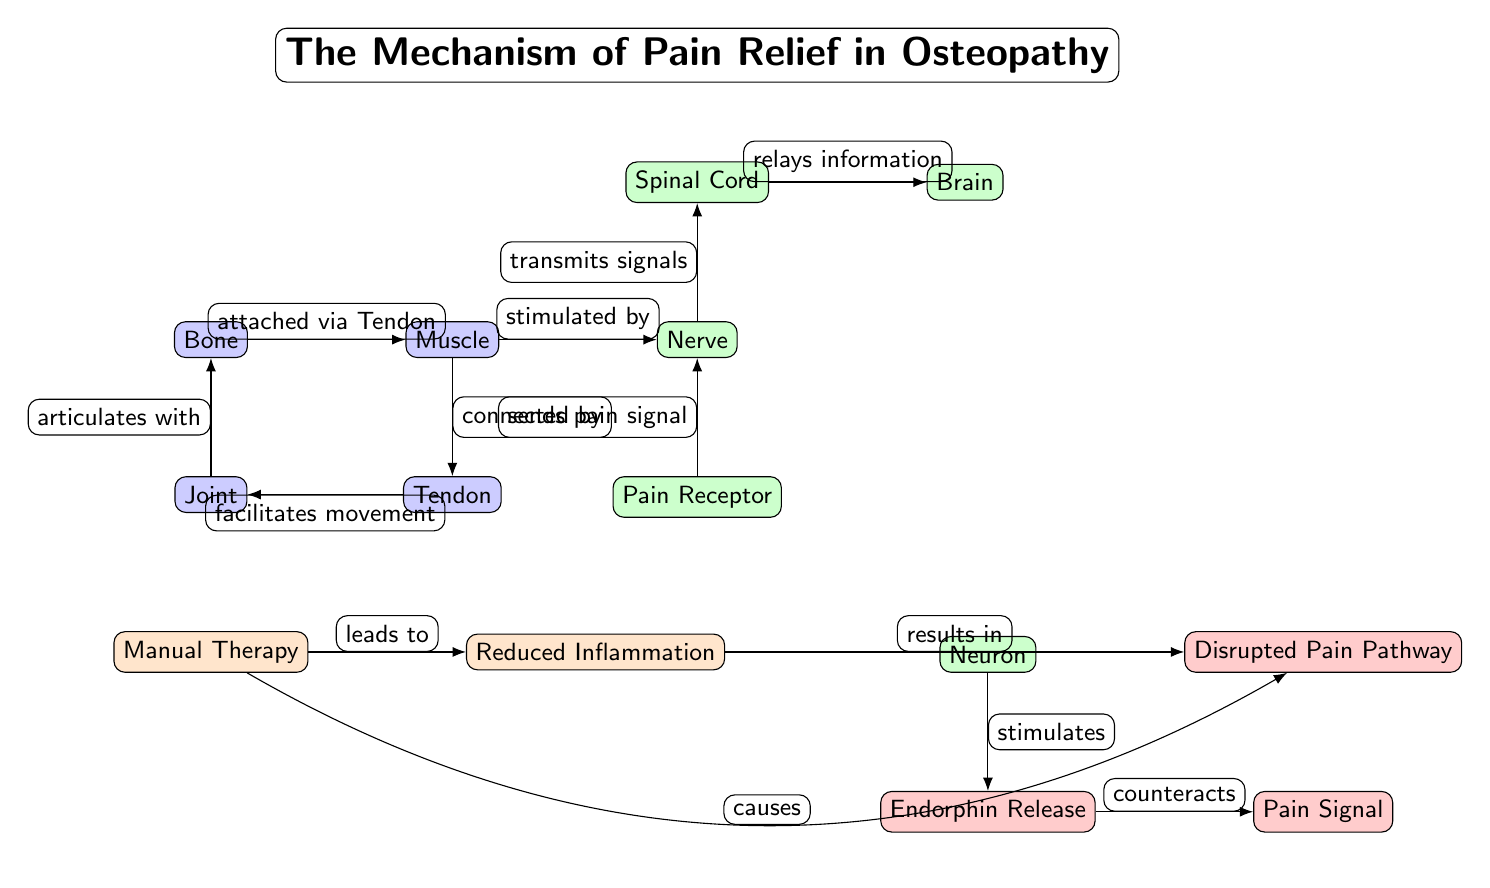What is the title of the diagram? The title is located at the top of the diagram, indicating the main subject being illustrated. It reads "The Mechanism of Pain Relief in Osteopathy."
Answer: The Mechanism of Pain Relief in Osteopathy How many musculoskeletal components are shown in the diagram? The diagram contains four musculoskeletal components: Bone, Muscle, Tendon, and Joint. By counting these nodes specifically, we arrive at the total.
Answer: 4 Which node sends a pain signal to the Nerve? The Pain Receptor node is indicated as sending a pain signal to the Nerve. This is clearly shown through the edge connecting these two nodes.
Answer: Pain Receptor What relationship does the Joint have with the Bone? The edge between Joint and Bone is labeled "articulates with," describing the connection between these two components in the musculoskeletal system.
Answer: articulates with What leads to the Reduced Inflammation in the diagram? The Manual Therapy node is indicated as the cause of Reduced Inflammation. This relationship is shown through the directed edge connecting the two.
Answer: Manual Therapy What is the final effect of Endorphin Release according to the diagram? The Endorphin Release node is connected to the Pain Signal node, with the edge labeled "counteracts," indicating the effect of endorphins on pain signals.
Answer: counteracts How does the Manual Therapy affect the Pain Pathway? Manual Therapy is described as causing a Disrupted Pain Pathway, which is depicted with an edge bending towards the Disrupted Pain Pathway node. This indicates a direct therapeutic effect.
Answer: causes Which components are part of the neural system in this diagram? The neural components include Nerve, Spinal Cord, Brain, Pain Receptor, and Neuron, as denoted by their respective labels and color coding within the diagram.
Answer: Nerve, Spinal Cord, Brain, Pain Receptor, Neuron How does the Nerve transmit the pain signal to the Brain? The Nerve transmits signals to the Spinal Cord, which then relays information to the Brain. This flow of information is shown through two connected edges in the diagram.
Answer: transmits signals 